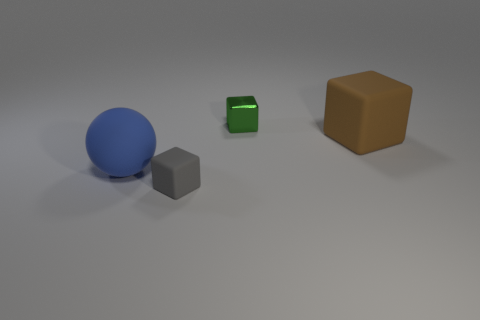The tiny rubber object has what color?
Offer a very short reply. Gray. How many other objects are the same color as the big block?
Make the answer very short. 0. There is a brown cube; are there any balls behind it?
Your answer should be compact. No. There is a matte block in front of the matte cube on the right side of the small thing that is behind the big brown matte cube; what is its color?
Your response must be concise. Gray. What number of objects are behind the small gray thing and right of the large blue rubber object?
Provide a short and direct response. 2. What number of blocks are brown matte things or tiny shiny things?
Provide a succinct answer. 2. Are any small blue blocks visible?
Provide a short and direct response. No. How many other objects are the same material as the blue ball?
Your answer should be compact. 2. What material is the thing that is the same size as the gray rubber block?
Keep it short and to the point. Metal. There is a big thing to the left of the small metallic object; does it have the same shape as the gray object?
Keep it short and to the point. No. 